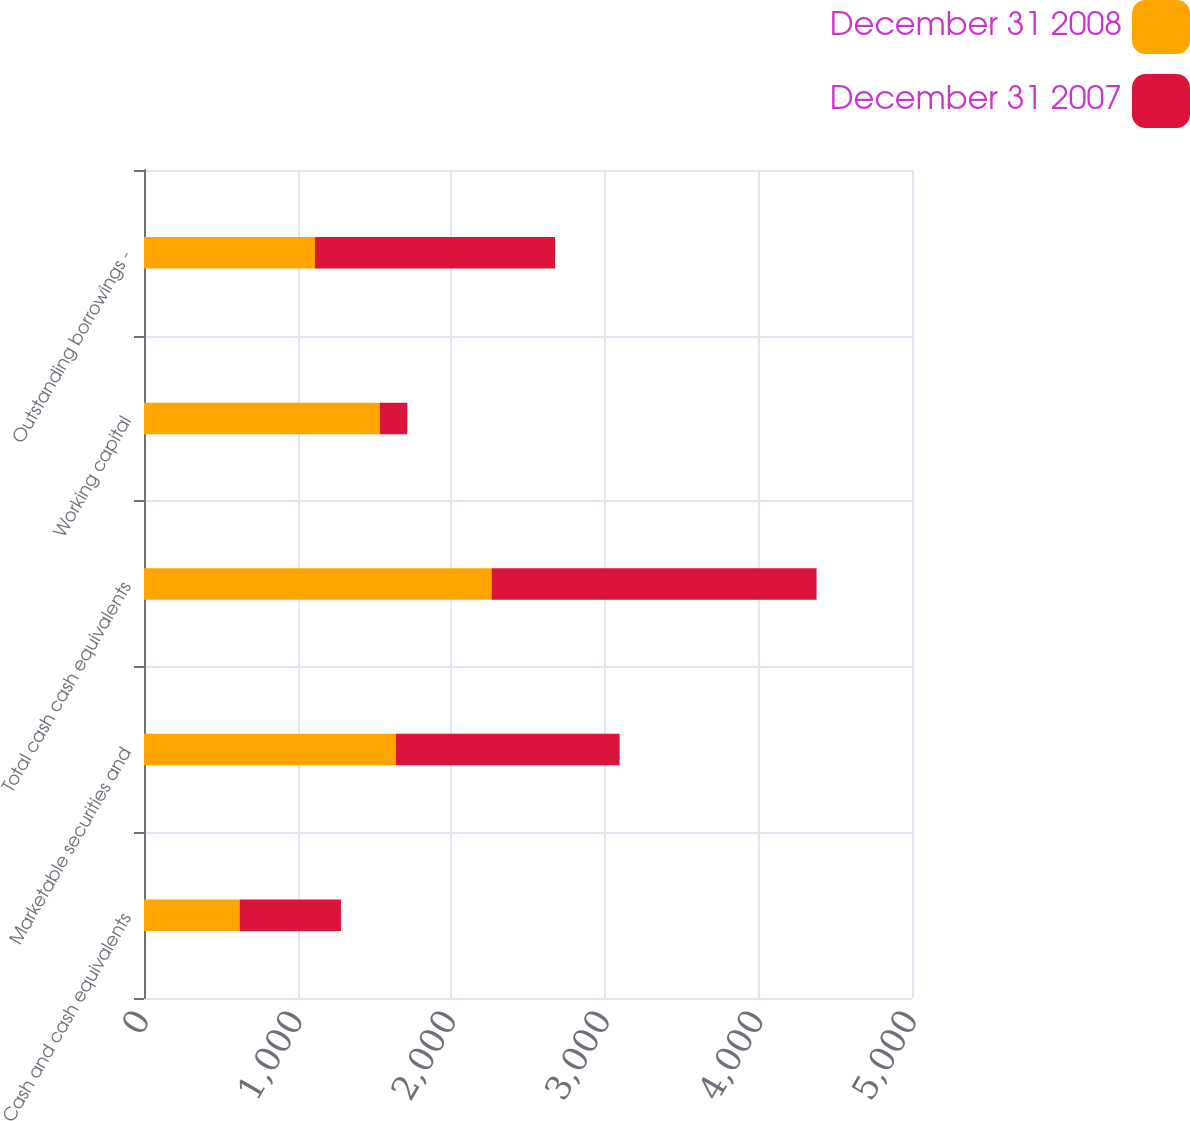<chart> <loc_0><loc_0><loc_500><loc_500><stacked_bar_chart><ecel><fcel>Cash and cash equivalents<fcel>Marketable securities and<fcel>Total cash cash equivalents<fcel>Working capital<fcel>Outstanding borrowings -<nl><fcel>December 31 2008<fcel>622.4<fcel>1640.4<fcel>2262.8<fcel>1534.8<fcel>1113.1<nl><fcel>December 31 2007<fcel>659.7<fcel>1456.1<fcel>2115.8<fcel>179.2<fcel>1563<nl></chart> 